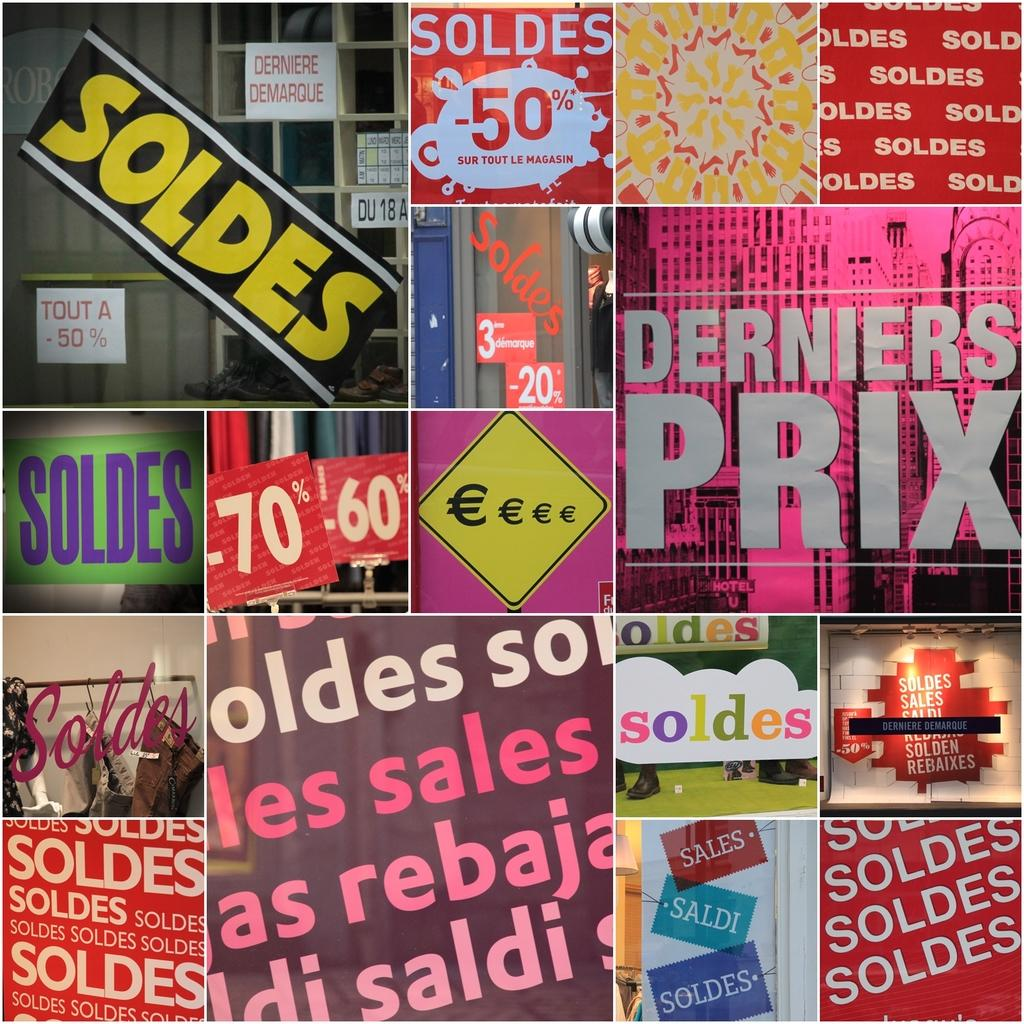<image>
Summarize the visual content of the image. A collage of pictures, many of which say Soldes. 